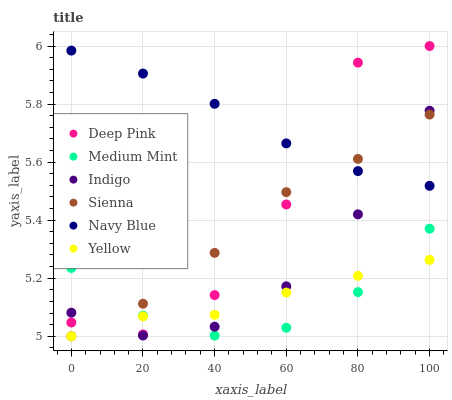Does Medium Mint have the minimum area under the curve?
Answer yes or no. Yes. Does Navy Blue have the maximum area under the curve?
Answer yes or no. Yes. Does Deep Pink have the minimum area under the curve?
Answer yes or no. No. Does Deep Pink have the maximum area under the curve?
Answer yes or no. No. Is Navy Blue the smoothest?
Answer yes or no. Yes. Is Deep Pink the roughest?
Answer yes or no. Yes. Is Indigo the smoothest?
Answer yes or no. No. Is Indigo the roughest?
Answer yes or no. No. Does Yellow have the lowest value?
Answer yes or no. Yes. Does Deep Pink have the lowest value?
Answer yes or no. No. Does Deep Pink have the highest value?
Answer yes or no. Yes. Does Indigo have the highest value?
Answer yes or no. No. Is Medium Mint less than Navy Blue?
Answer yes or no. Yes. Is Navy Blue greater than Yellow?
Answer yes or no. Yes. Does Navy Blue intersect Indigo?
Answer yes or no. Yes. Is Navy Blue less than Indigo?
Answer yes or no. No. Is Navy Blue greater than Indigo?
Answer yes or no. No. Does Medium Mint intersect Navy Blue?
Answer yes or no. No. 